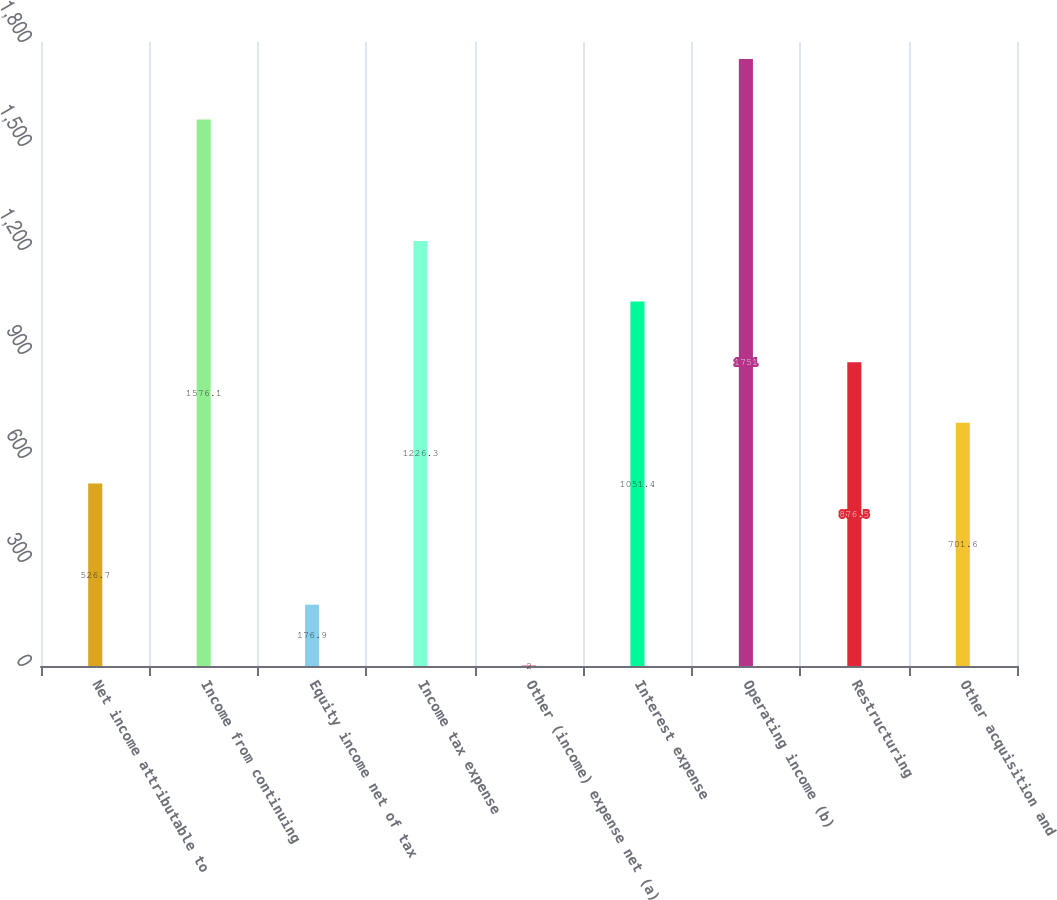Convert chart to OTSL. <chart><loc_0><loc_0><loc_500><loc_500><bar_chart><fcel>Net income attributable to<fcel>Income from continuing<fcel>Equity income net of tax<fcel>Income tax expense<fcel>Other (income) expense net (a)<fcel>Interest expense<fcel>Operating income (b)<fcel>Restructuring<fcel>Other acquisition and<nl><fcel>526.7<fcel>1576.1<fcel>176.9<fcel>1226.3<fcel>2<fcel>1051.4<fcel>1751<fcel>876.5<fcel>701.6<nl></chart> 